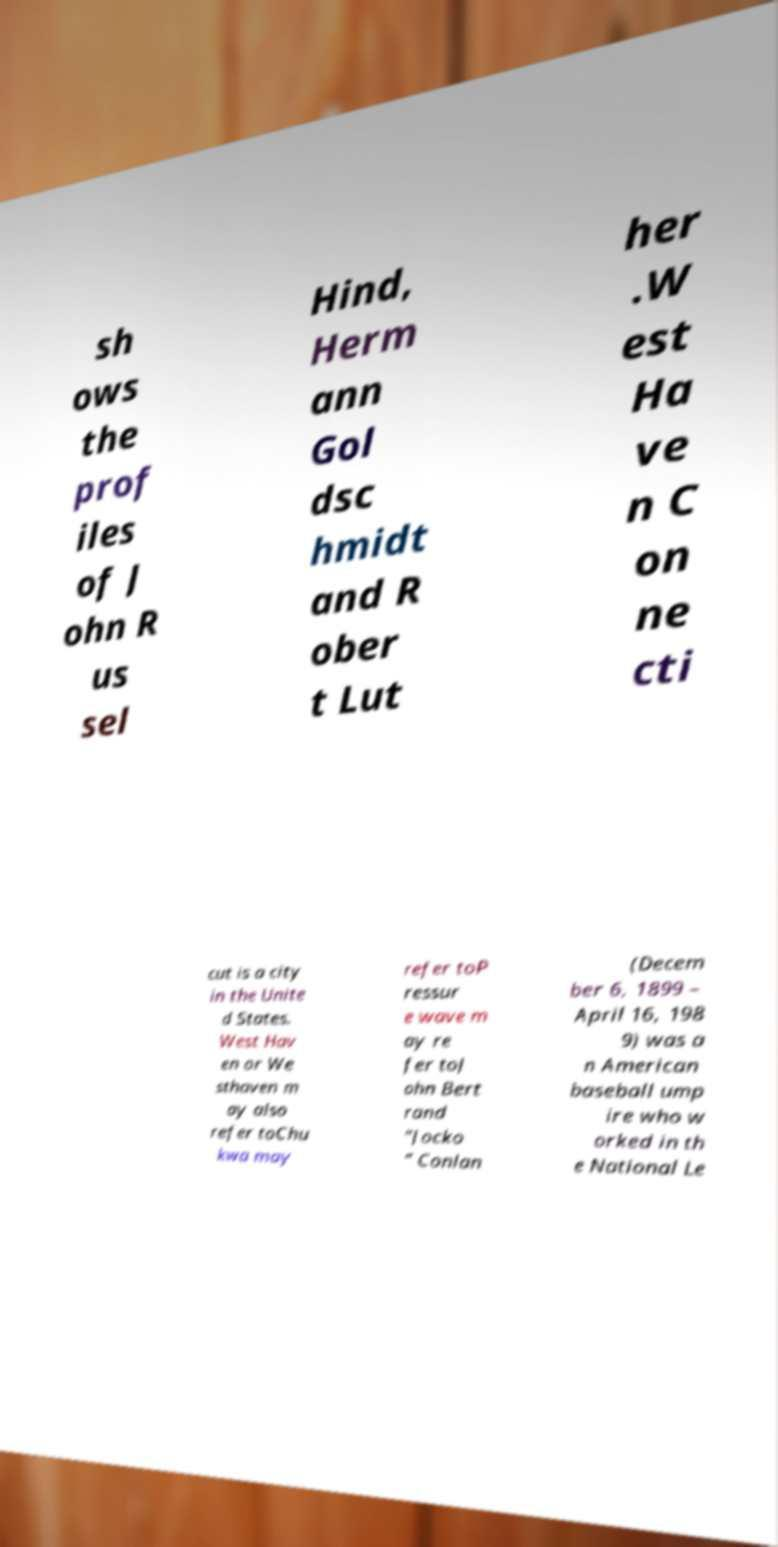Could you extract and type out the text from this image? sh ows the prof iles of J ohn R us sel Hind, Herm ann Gol dsc hmidt and R ober t Lut her .W est Ha ve n C on ne cti cut is a city in the Unite d States. West Hav en or We sthaven m ay also refer toChu kwa may refer toP ressur e wave m ay re fer toJ ohn Bert rand "Jocko " Conlan (Decem ber 6, 1899 – April 16, 198 9) was a n American baseball ump ire who w orked in th e National Le 